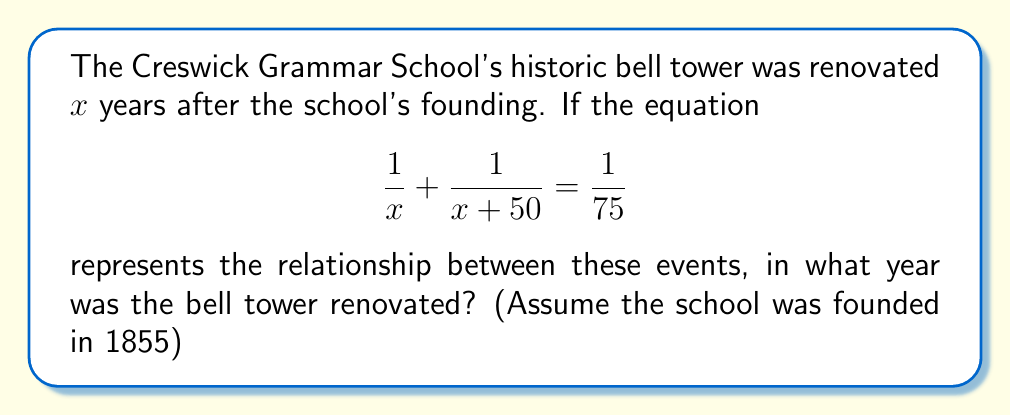Provide a solution to this math problem. Let's solve this step-by-step:

1) We start with the equation: $\frac{1}{x} + \frac{1}{x+50} = \frac{1}{75}$

2) To solve this, we need to find a common denominator. The LCD is $x(x+50)$:
   $\frac{x+50}{x(x+50)} + \frac{x}{x(x+50)} = \frac{1}{75}$

3) Simplify the left side:
   $\frac{x+50+x}{x(x+50)} = \frac{1}{75}$

4) Simplify the numerator:
   $\frac{2x+50}{x(x+50)} = \frac{1}{75}$

5) Cross multiply:
   $75(2x+50) = x(x+50)$

6) Expand:
   $150x + 3750 = x^2 + 50x$

7) Rearrange to standard form:
   $x^2 - 100x - 3750 = 0$

8) This is a quadratic equation. We can solve it using the quadratic formula:
   $x = \frac{-b \pm \sqrt{b^2 - 4ac}}{2a}$

   Where $a=1$, $b=-100$, and $c=-3750$

9) Plugging in these values:
   $x = \frac{100 \pm \sqrt{10000 + 15000}}{2} = \frac{100 \pm \sqrt{25000}}{2}$

10) Simplify:
    $x = \frac{100 \pm 158.11}{2}$

11) This gives us two solutions:
    $x = 129.06$ or $x = -29.06$

12) Since we're dealing with years, we take the positive solution: $x \approx 129$

13) The school was founded in 1855, so the renovation year would be:
    1855 + 129 = 1984

Therefore, the bell tower was renovated in 1984.
Answer: 1984 